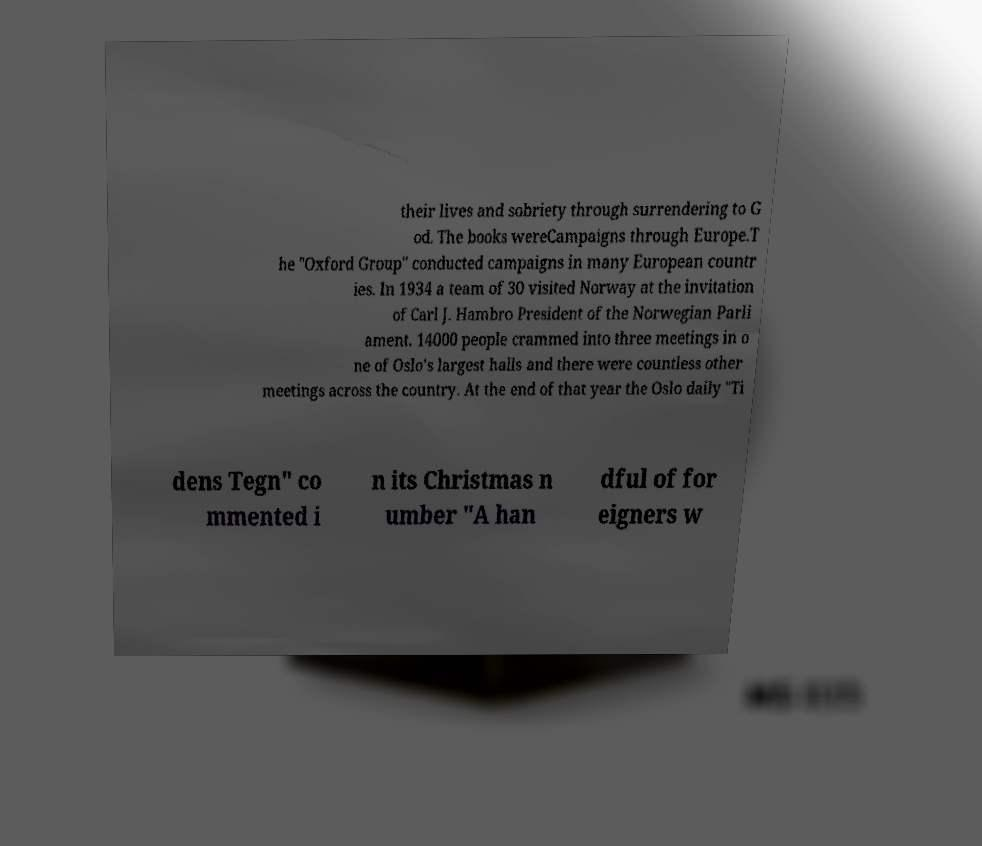Can you accurately transcribe the text from the provided image for me? their lives and sobriety through surrendering to G od. The books wereCampaigns through Europe.T he "Oxford Group" conducted campaigns in many European countr ies. In 1934 a team of 30 visited Norway at the invitation of Carl J. Hambro President of the Norwegian Parli ament. 14000 people crammed into three meetings in o ne of Oslo's largest halls and there were countless other meetings across the country. At the end of that year the Oslo daily "Ti dens Tegn" co mmented i n its Christmas n umber "A han dful of for eigners w 